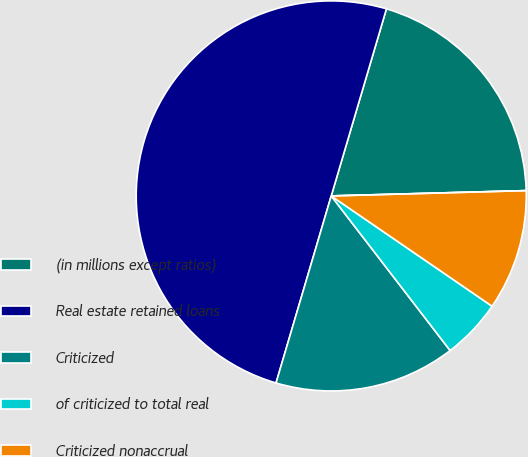<chart> <loc_0><loc_0><loc_500><loc_500><pie_chart><fcel>(in millions except ratios)<fcel>Real estate retained loans<fcel>Criticized<fcel>of criticized to total real<fcel>Criticized nonaccrual<fcel>of criticized nonaccrual to<nl><fcel>20.0%<fcel>50.0%<fcel>15.0%<fcel>5.0%<fcel>10.0%<fcel>0.0%<nl></chart> 